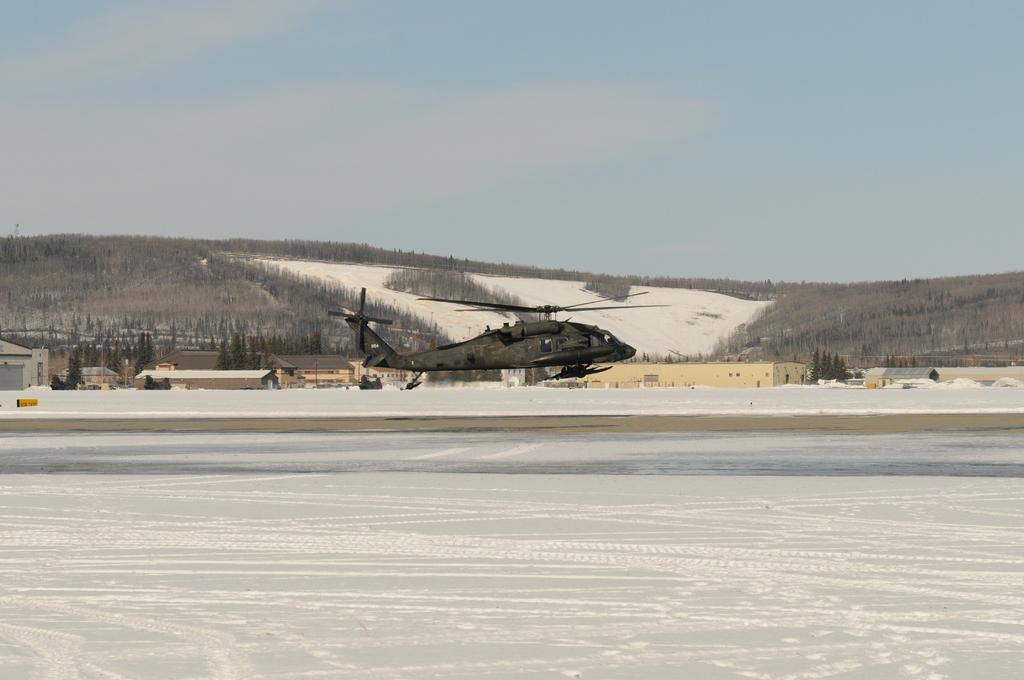Please provide a concise description of this image. At the bottom of the image there is snow on the ground. And there is a helicopter in the air. Behind the helicopter there are buildings with roofs and walls. And also there are trees. In the background there is a hill with trees. At the top of the image there is a sky. 